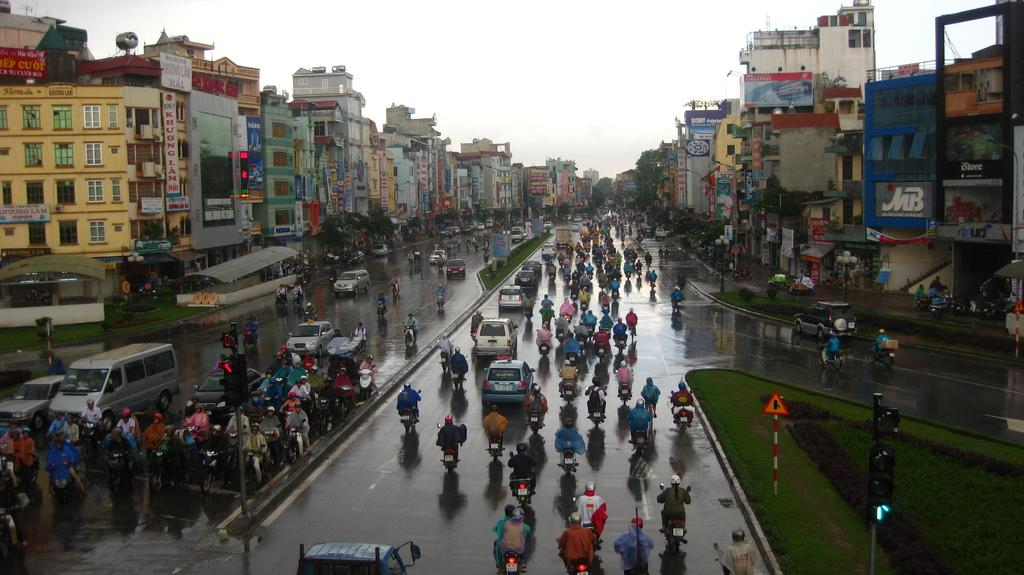What can be seen in the sky in the image? The sky is visible in the image. What type of structures are present in the image? There are buildings, stores, sheds, and traffic poles in the image. What are the name boards used for in the image? Name boards are visible in the image to identify the stores or businesses. What type of vegetation is visible in the image? Trees are visible in the image. How is the ground represented in the image? The ground is visible in the image. What type of transportation can be seen in the image? There are persons on motor vehicles in the image. What type of signals are present in the image? Traffic signals are visible in the image. What are the sign boards used for in the image? Sign boards are present in the image to provide information or directions. How many dolls are sitting on the traffic signal in the image? There are no dolls present in the image, and therefore none can be found sitting on the traffic signal. 